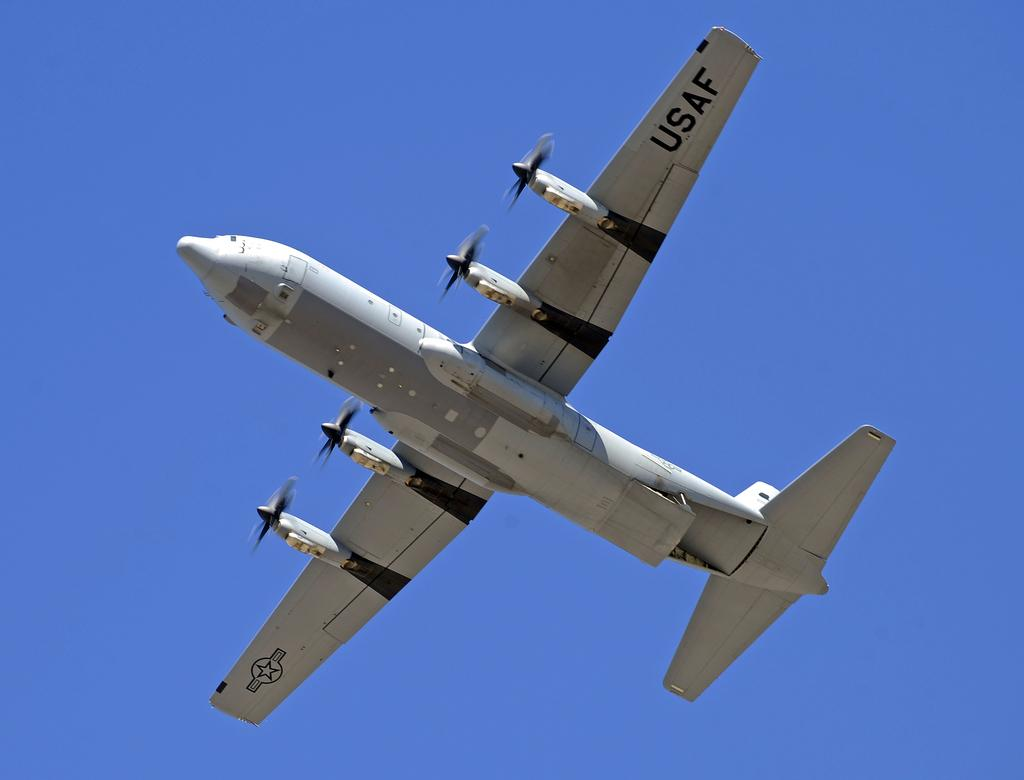<image>
Share a concise interpretation of the image provided. An airplane with the letters USAF written on the left wing 